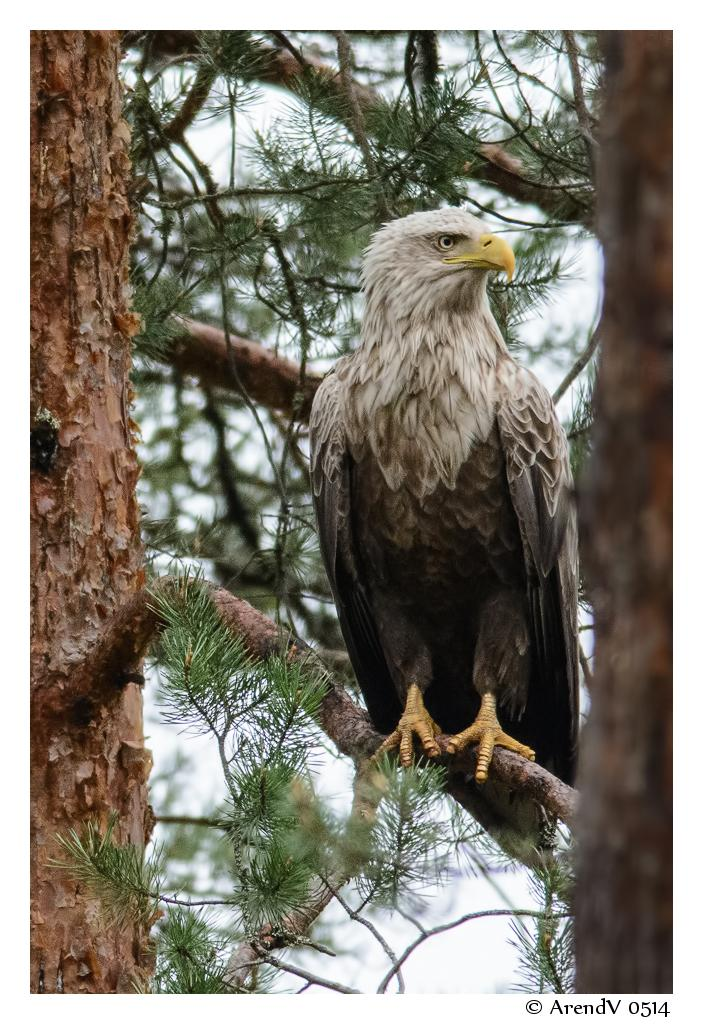What type of bird is in the image? There is an eagle in the image. Can you describe the colors of the eagle? The eagle has cream, yellow, brown, and black coloring. Where is the eagle located in the image? The eagle is on a tree. What can be seen in the background of the image? The sky is visible in the background of the image. What type of suit is the eagle wearing in the image? There is no suit present in the image, as eagles are birds and do not wear clothing. 